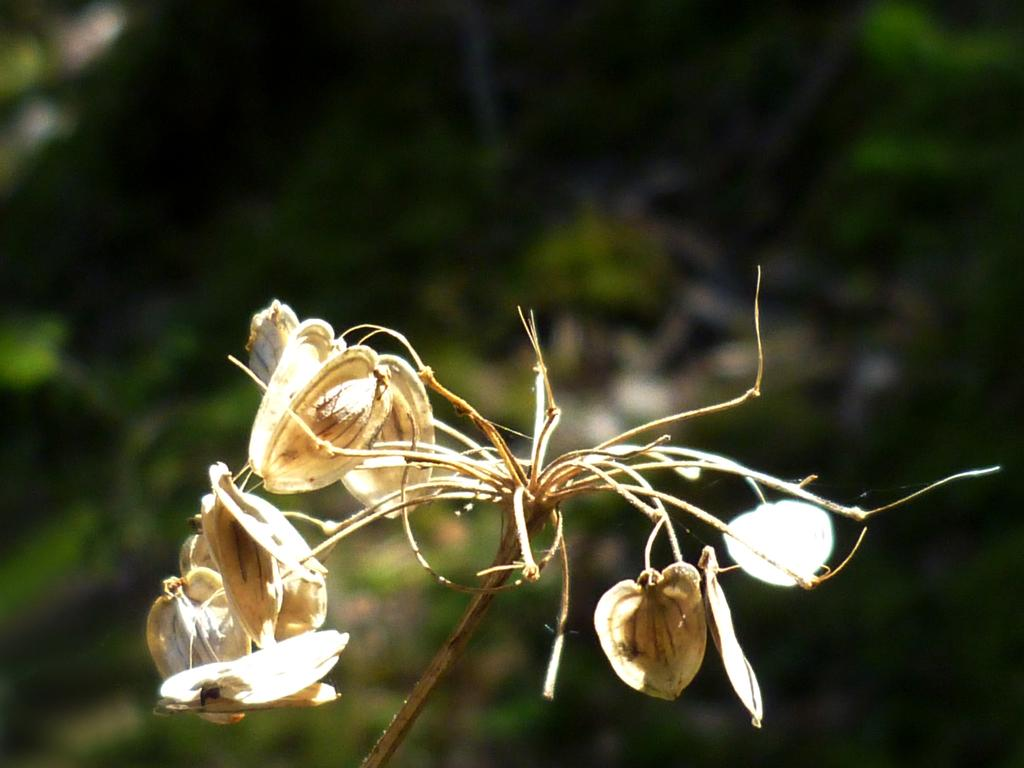What type of flowers are in the image? There are dry flowers on a stem in the image. What can be seen in the background of the image? The background of the image is green. What type of knowledge can be gained from the river in the image? There is no river present in the image, so no knowledge can be gained from it. What kind of apparatus is used to maintain the dry flowers in the image? There is no apparatus visible in the image; the dry flowers are simply on a stem. 